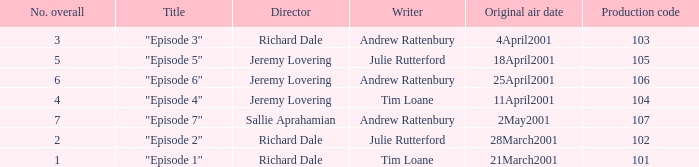What is the highest production code of an episode written by Tim Loane? 104.0. 